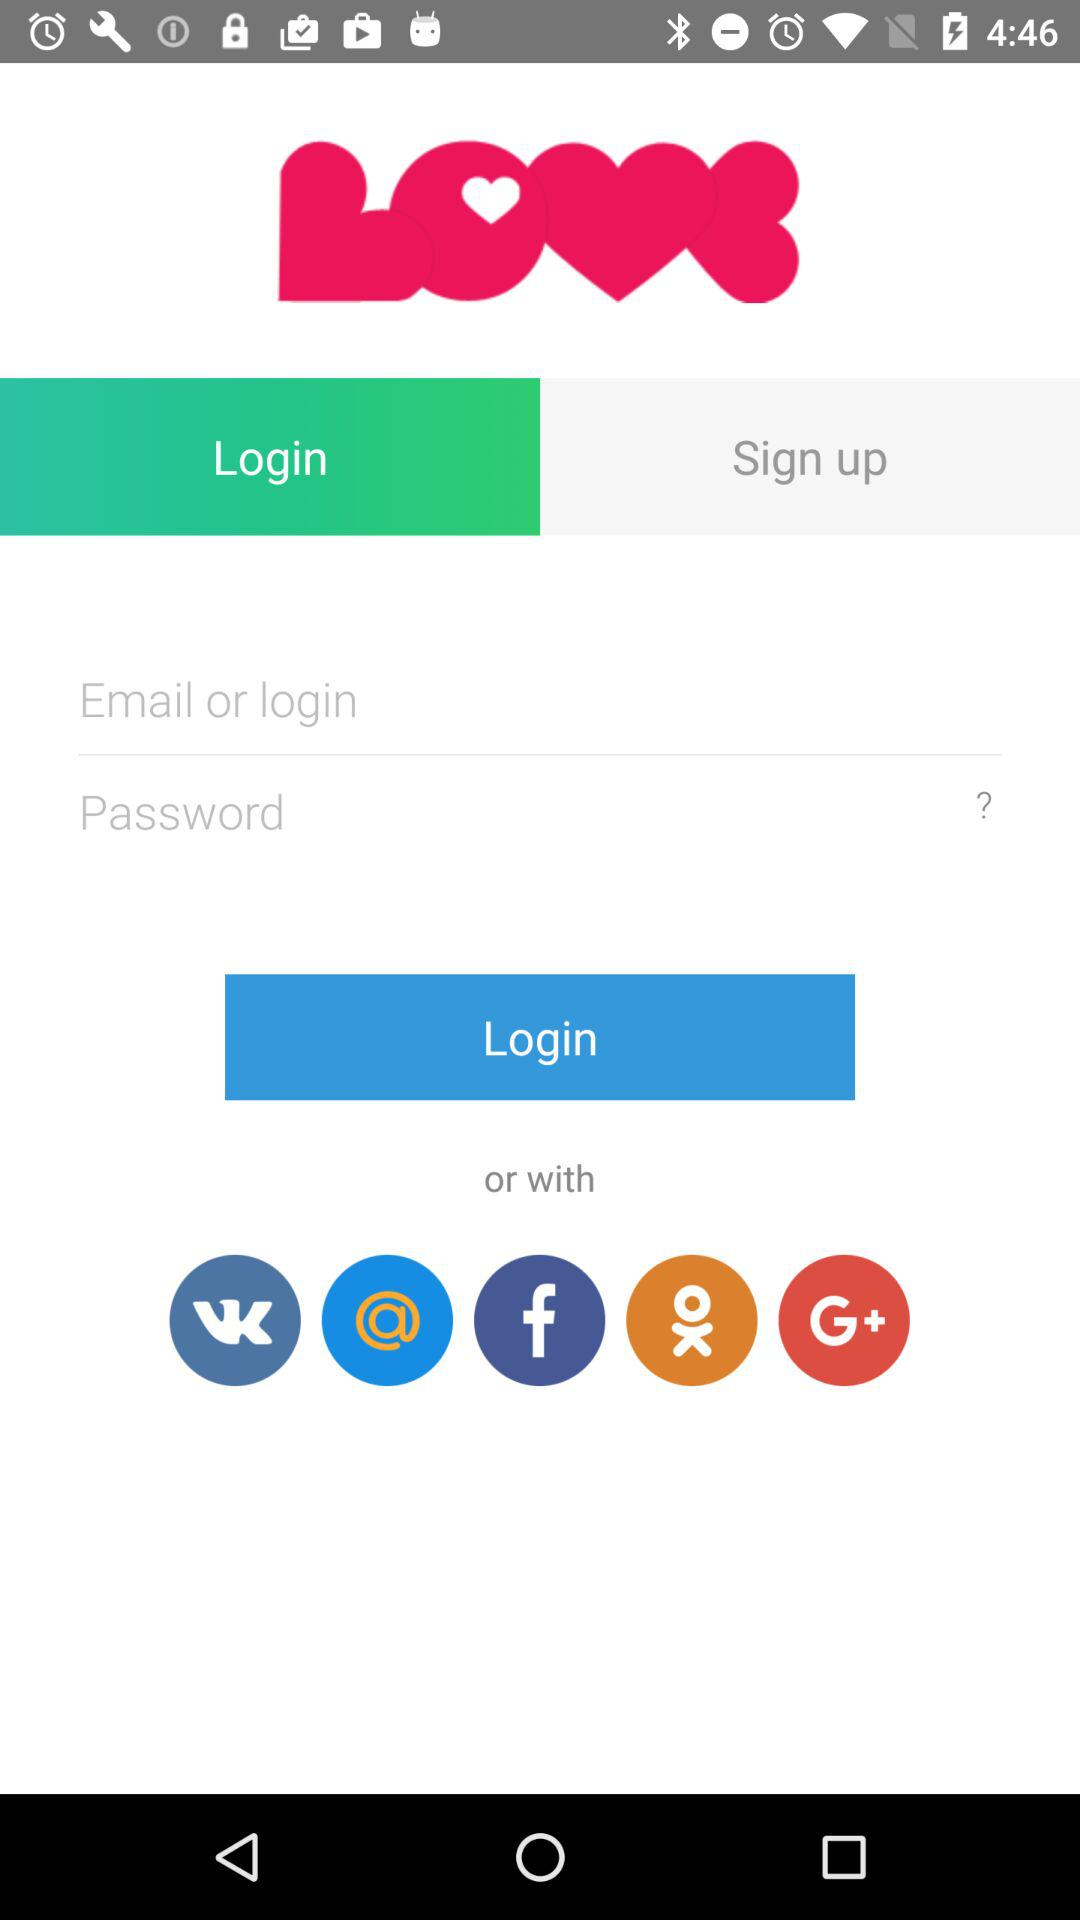Which are the different login options? The different login options are "Email", "vk", "Mail.ru", "Facebook", "OK" and "Google+". 